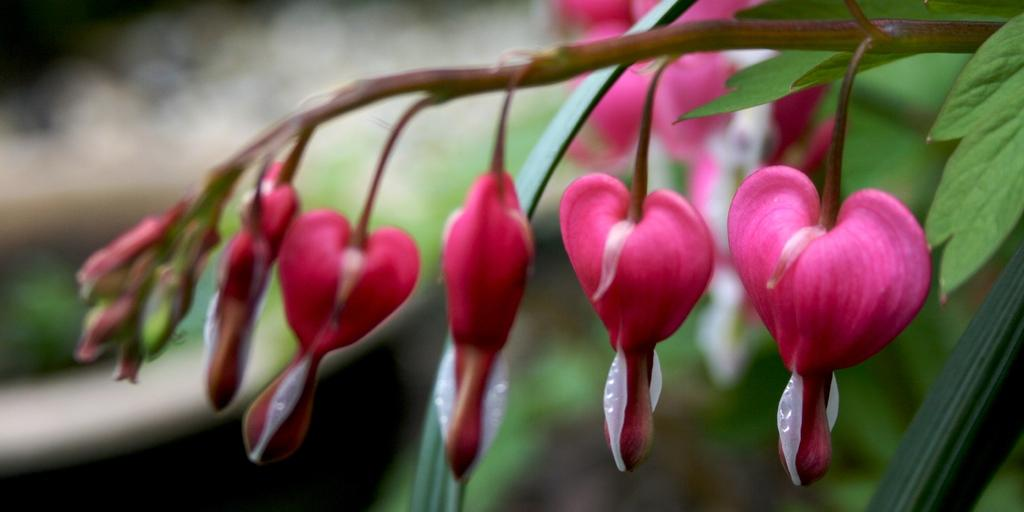What is the main subject of the image? There is a flower in the image. What color is the flower? The flower is pink in color. Are there any other parts of the plant visible in the image? Yes, there are leaves in the image. What type of oil is being used to water the flower in the image? There is no oil present in the image, and the flower is not being watered. 